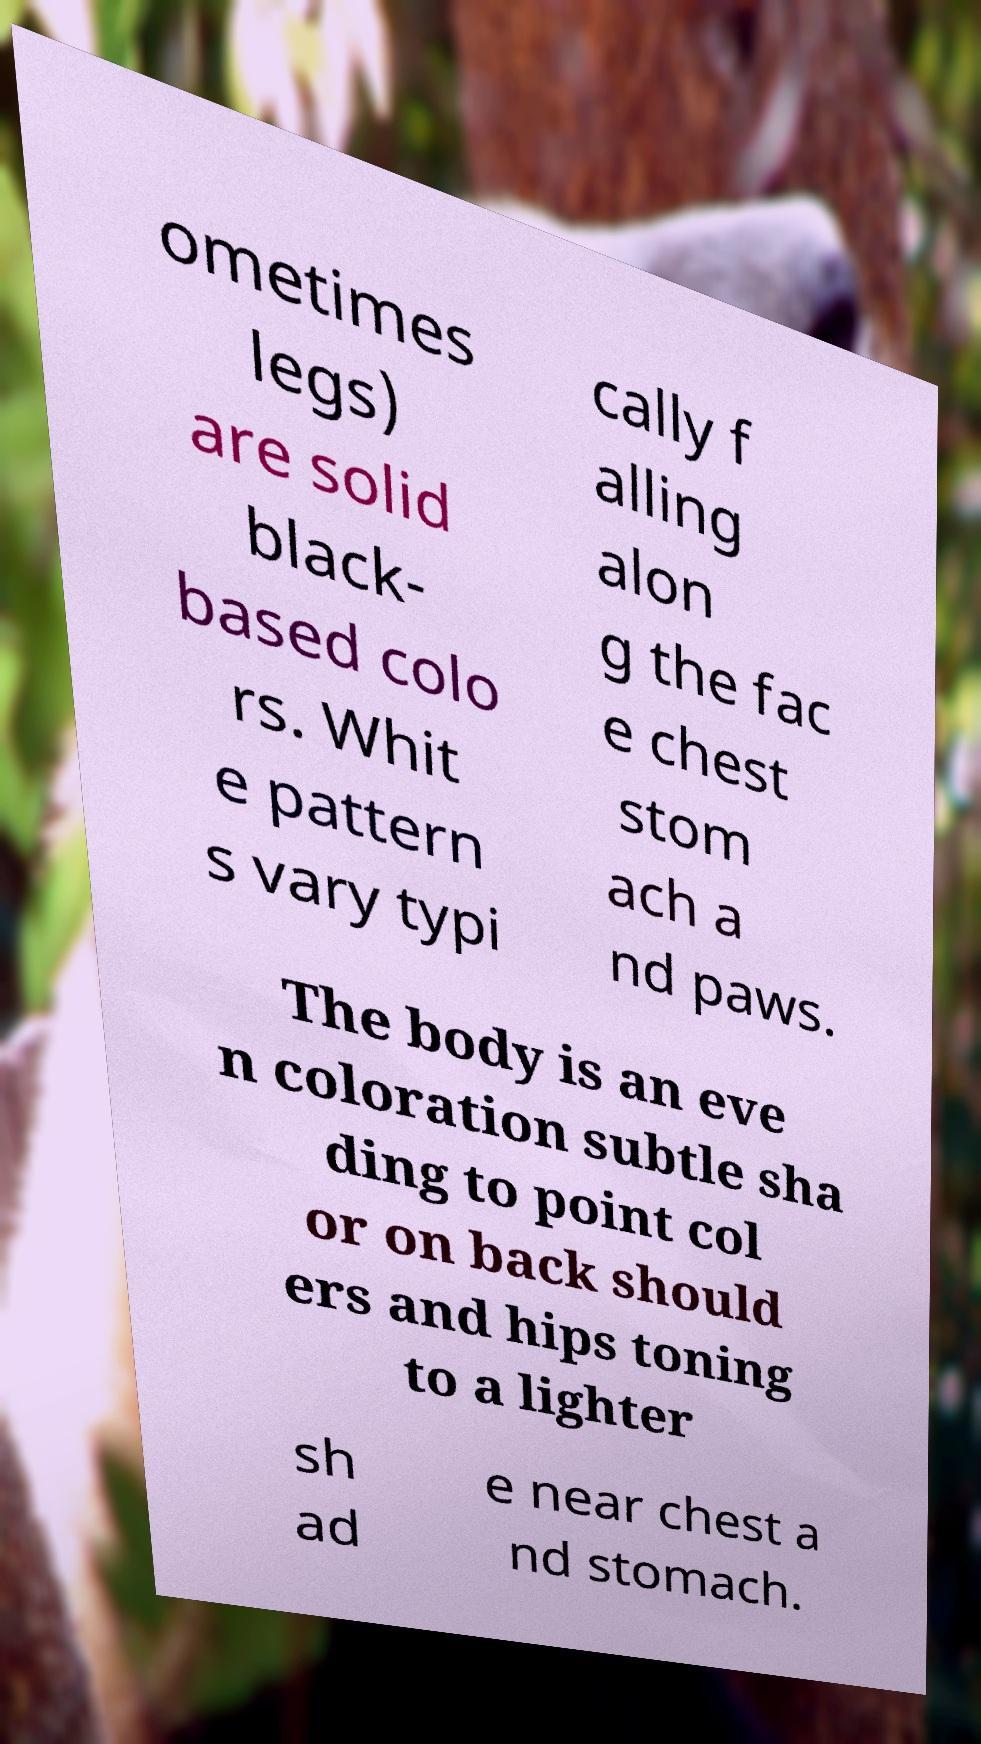Can you accurately transcribe the text from the provided image for me? ometimes legs) are solid black- based colo rs. Whit e pattern s vary typi cally f alling alon g the fac e chest stom ach a nd paws. The body is an eve n coloration subtle sha ding to point col or on back should ers and hips toning to a lighter sh ad e near chest a nd stomach. 